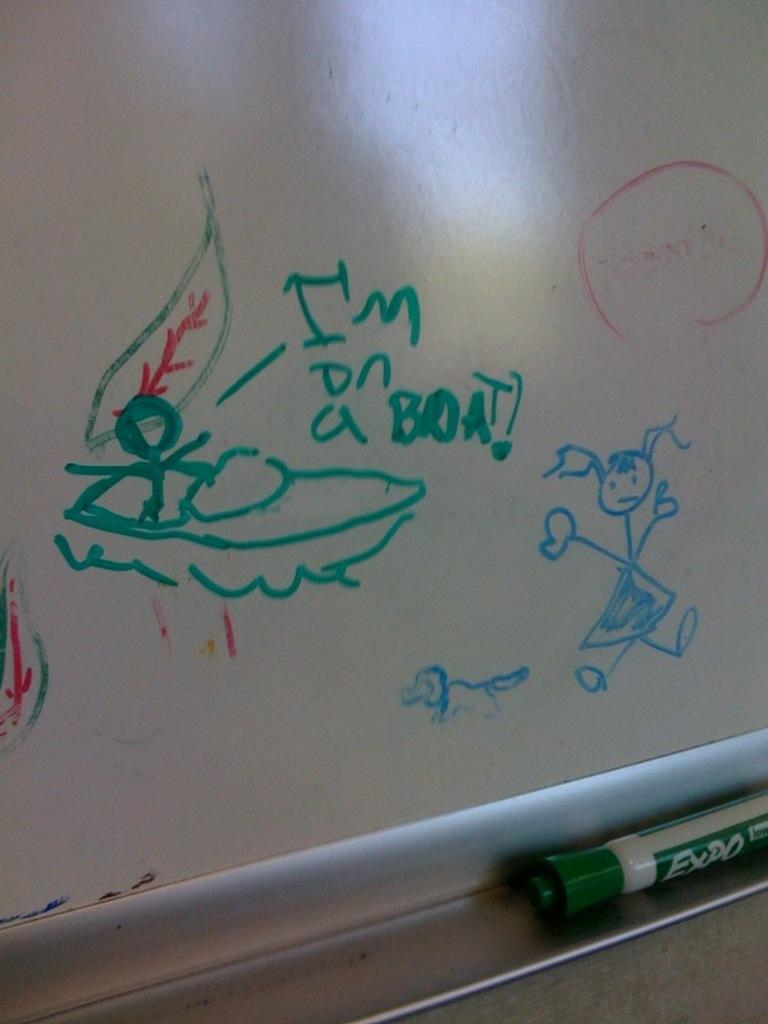<image>
Give a short and clear explanation of the subsequent image. A character on a white board exclaims it is on a boat. 